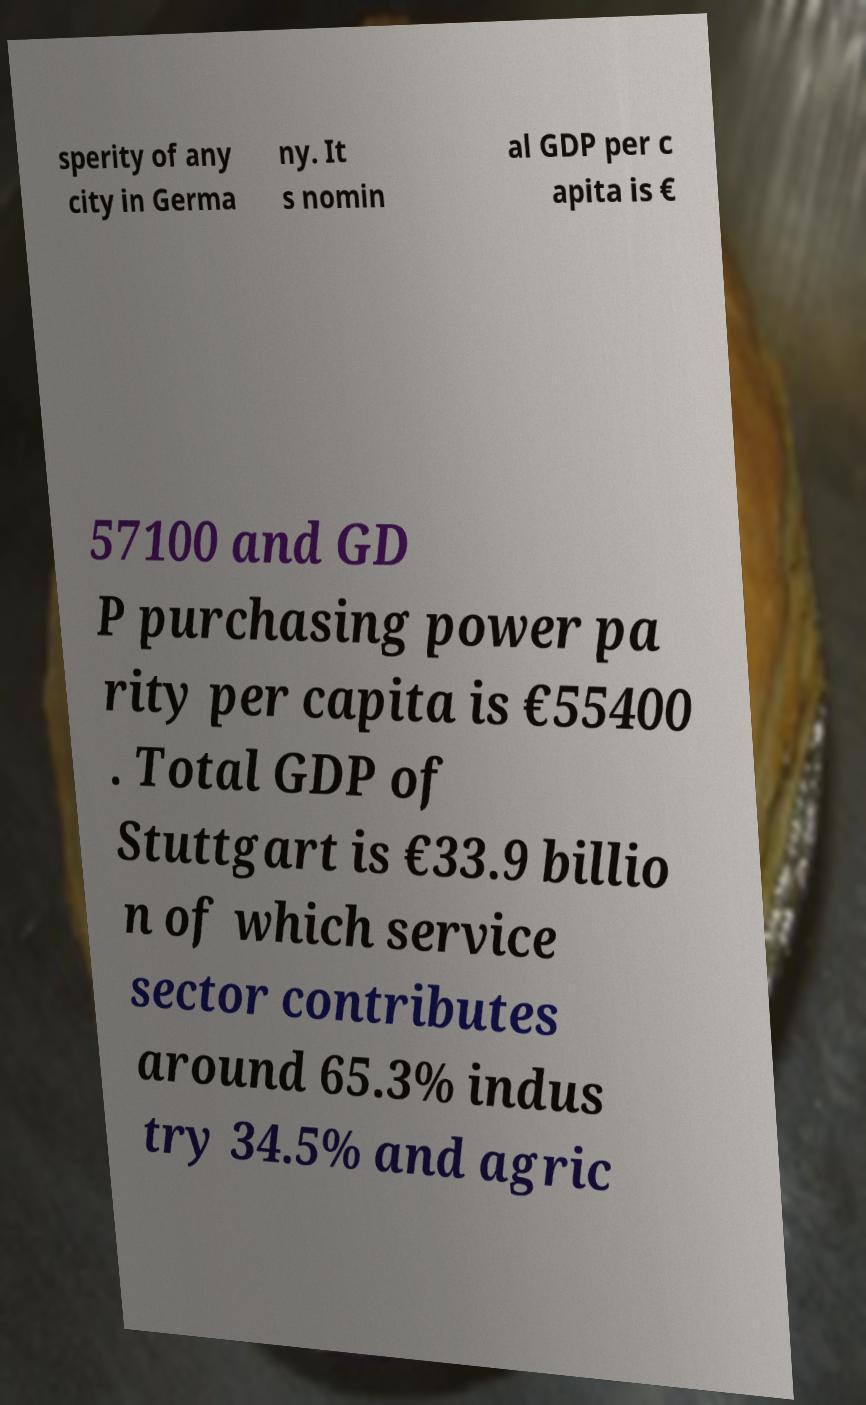Please read and relay the text visible in this image. What does it say? sperity of any city in Germa ny. It s nomin al GDP per c apita is € 57100 and GD P purchasing power pa rity per capita is €55400 . Total GDP of Stuttgart is €33.9 billio n of which service sector contributes around 65.3% indus try 34.5% and agric 